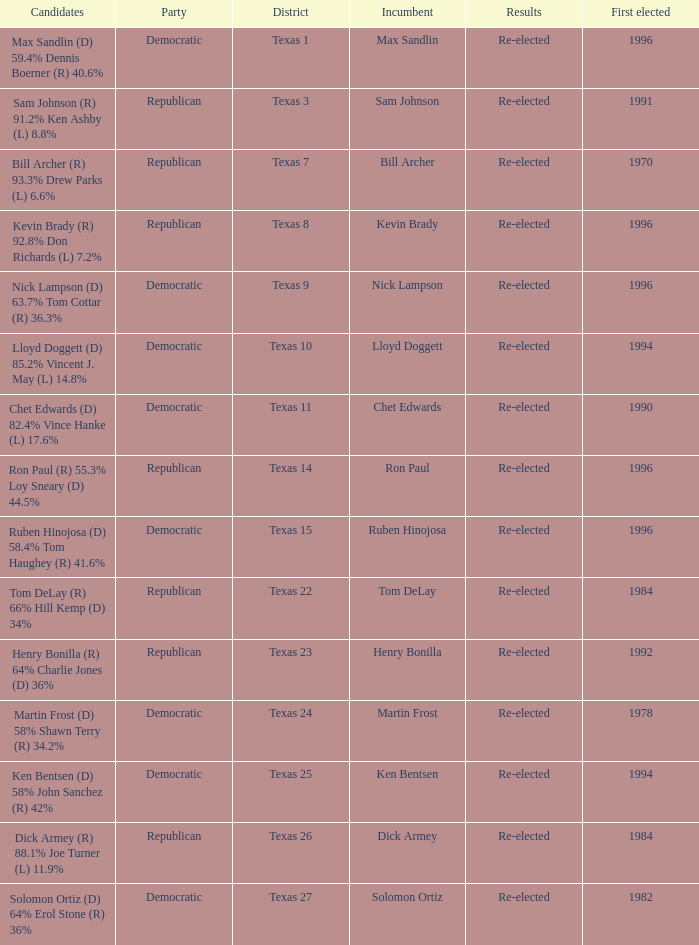What district is ruben hinojosa from? Texas 15. 